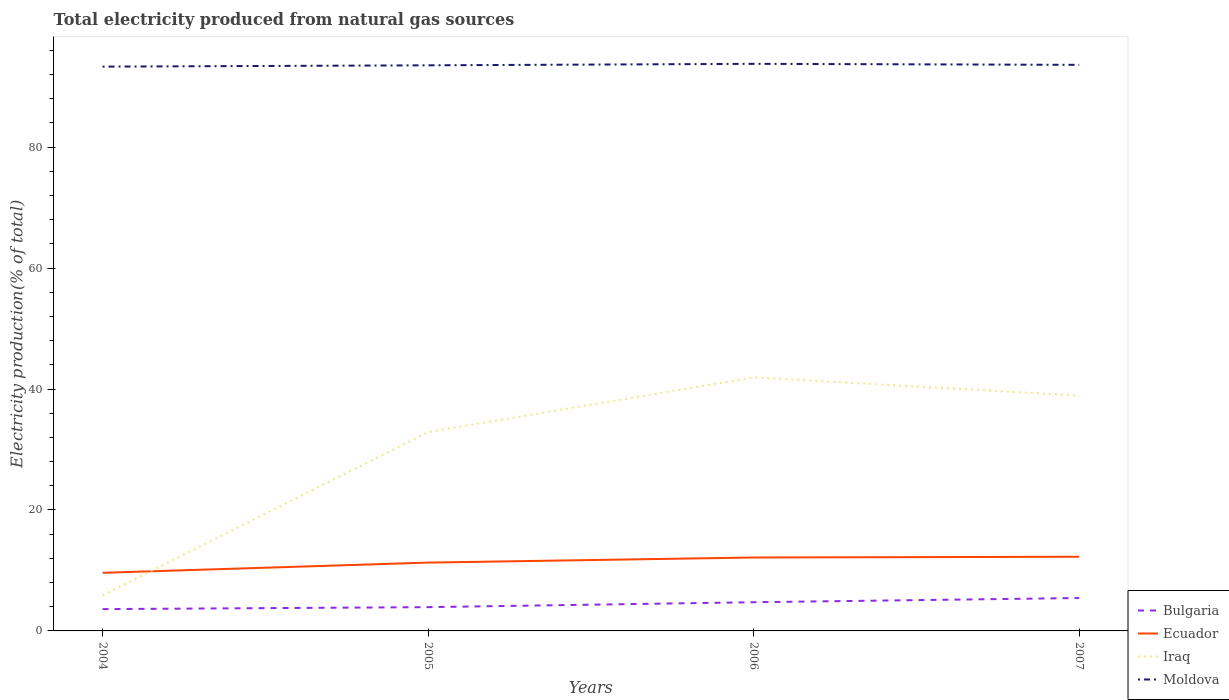How many different coloured lines are there?
Offer a terse response. 4. Does the line corresponding to Moldova intersect with the line corresponding to Bulgaria?
Your answer should be very brief. No. Across all years, what is the maximum total electricity produced in Moldova?
Provide a short and direct response. 93.32. What is the total total electricity produced in Iraq in the graph?
Provide a short and direct response. -33.04. What is the difference between the highest and the second highest total electricity produced in Bulgaria?
Your response must be concise. 1.83. Is the total electricity produced in Ecuador strictly greater than the total electricity produced in Moldova over the years?
Give a very brief answer. Yes. How many lines are there?
Your response must be concise. 4. How many years are there in the graph?
Your answer should be very brief. 4. How are the legend labels stacked?
Offer a very short reply. Vertical. What is the title of the graph?
Provide a short and direct response. Total electricity produced from natural gas sources. Does "Ireland" appear as one of the legend labels in the graph?
Offer a very short reply. No. What is the label or title of the X-axis?
Give a very brief answer. Years. What is the label or title of the Y-axis?
Keep it short and to the point. Electricity production(% of total). What is the Electricity production(% of total) of Bulgaria in 2004?
Your response must be concise. 3.61. What is the Electricity production(% of total) in Ecuador in 2004?
Offer a terse response. 9.61. What is the Electricity production(% of total) in Iraq in 2004?
Offer a very short reply. 5.88. What is the Electricity production(% of total) of Moldova in 2004?
Give a very brief answer. 93.32. What is the Electricity production(% of total) in Bulgaria in 2005?
Your response must be concise. 3.93. What is the Electricity production(% of total) of Ecuador in 2005?
Make the answer very short. 11.3. What is the Electricity production(% of total) of Iraq in 2005?
Offer a terse response. 32.89. What is the Electricity production(% of total) of Moldova in 2005?
Keep it short and to the point. 93.54. What is the Electricity production(% of total) in Bulgaria in 2006?
Offer a very short reply. 4.74. What is the Electricity production(% of total) of Ecuador in 2006?
Your response must be concise. 12.14. What is the Electricity production(% of total) in Iraq in 2006?
Provide a short and direct response. 41.93. What is the Electricity production(% of total) of Moldova in 2006?
Offer a very short reply. 93.78. What is the Electricity production(% of total) of Bulgaria in 2007?
Keep it short and to the point. 5.44. What is the Electricity production(% of total) of Ecuador in 2007?
Ensure brevity in your answer.  12.27. What is the Electricity production(% of total) of Iraq in 2007?
Provide a succinct answer. 38.92. What is the Electricity production(% of total) in Moldova in 2007?
Give a very brief answer. 93.62. Across all years, what is the maximum Electricity production(% of total) of Bulgaria?
Ensure brevity in your answer.  5.44. Across all years, what is the maximum Electricity production(% of total) of Ecuador?
Give a very brief answer. 12.27. Across all years, what is the maximum Electricity production(% of total) in Iraq?
Offer a very short reply. 41.93. Across all years, what is the maximum Electricity production(% of total) in Moldova?
Make the answer very short. 93.78. Across all years, what is the minimum Electricity production(% of total) of Bulgaria?
Give a very brief answer. 3.61. Across all years, what is the minimum Electricity production(% of total) of Ecuador?
Offer a very short reply. 9.61. Across all years, what is the minimum Electricity production(% of total) in Iraq?
Your answer should be compact. 5.88. Across all years, what is the minimum Electricity production(% of total) in Moldova?
Make the answer very short. 93.32. What is the total Electricity production(% of total) of Bulgaria in the graph?
Offer a terse response. 17.72. What is the total Electricity production(% of total) of Ecuador in the graph?
Make the answer very short. 45.32. What is the total Electricity production(% of total) of Iraq in the graph?
Give a very brief answer. 119.63. What is the total Electricity production(% of total) in Moldova in the graph?
Offer a terse response. 374.26. What is the difference between the Electricity production(% of total) of Bulgaria in 2004 and that in 2005?
Your response must be concise. -0.33. What is the difference between the Electricity production(% of total) in Ecuador in 2004 and that in 2005?
Offer a very short reply. -1.69. What is the difference between the Electricity production(% of total) of Iraq in 2004 and that in 2005?
Make the answer very short. -27.01. What is the difference between the Electricity production(% of total) of Moldova in 2004 and that in 2005?
Your answer should be compact. -0.22. What is the difference between the Electricity production(% of total) of Bulgaria in 2004 and that in 2006?
Ensure brevity in your answer.  -1.14. What is the difference between the Electricity production(% of total) of Ecuador in 2004 and that in 2006?
Your answer should be very brief. -2.53. What is the difference between the Electricity production(% of total) in Iraq in 2004 and that in 2006?
Your answer should be compact. -36.05. What is the difference between the Electricity production(% of total) in Moldova in 2004 and that in 2006?
Your response must be concise. -0.46. What is the difference between the Electricity production(% of total) of Bulgaria in 2004 and that in 2007?
Make the answer very short. -1.83. What is the difference between the Electricity production(% of total) in Ecuador in 2004 and that in 2007?
Make the answer very short. -2.66. What is the difference between the Electricity production(% of total) in Iraq in 2004 and that in 2007?
Provide a succinct answer. -33.04. What is the difference between the Electricity production(% of total) in Moldova in 2004 and that in 2007?
Ensure brevity in your answer.  -0.29. What is the difference between the Electricity production(% of total) in Bulgaria in 2005 and that in 2006?
Your answer should be compact. -0.81. What is the difference between the Electricity production(% of total) of Ecuador in 2005 and that in 2006?
Offer a terse response. -0.84. What is the difference between the Electricity production(% of total) in Iraq in 2005 and that in 2006?
Your answer should be very brief. -9.04. What is the difference between the Electricity production(% of total) in Moldova in 2005 and that in 2006?
Keep it short and to the point. -0.24. What is the difference between the Electricity production(% of total) in Bulgaria in 2005 and that in 2007?
Offer a very short reply. -1.51. What is the difference between the Electricity production(% of total) in Ecuador in 2005 and that in 2007?
Provide a short and direct response. -0.97. What is the difference between the Electricity production(% of total) in Iraq in 2005 and that in 2007?
Make the answer very short. -6.03. What is the difference between the Electricity production(% of total) in Moldova in 2005 and that in 2007?
Your response must be concise. -0.08. What is the difference between the Electricity production(% of total) of Bulgaria in 2006 and that in 2007?
Your answer should be very brief. -0.7. What is the difference between the Electricity production(% of total) of Ecuador in 2006 and that in 2007?
Offer a terse response. -0.12. What is the difference between the Electricity production(% of total) of Iraq in 2006 and that in 2007?
Make the answer very short. 3.01. What is the difference between the Electricity production(% of total) of Moldova in 2006 and that in 2007?
Provide a short and direct response. 0.17. What is the difference between the Electricity production(% of total) of Bulgaria in 2004 and the Electricity production(% of total) of Ecuador in 2005?
Offer a very short reply. -7.69. What is the difference between the Electricity production(% of total) in Bulgaria in 2004 and the Electricity production(% of total) in Iraq in 2005?
Provide a short and direct response. -29.29. What is the difference between the Electricity production(% of total) in Bulgaria in 2004 and the Electricity production(% of total) in Moldova in 2005?
Provide a succinct answer. -89.93. What is the difference between the Electricity production(% of total) of Ecuador in 2004 and the Electricity production(% of total) of Iraq in 2005?
Your answer should be compact. -23.29. What is the difference between the Electricity production(% of total) in Ecuador in 2004 and the Electricity production(% of total) in Moldova in 2005?
Give a very brief answer. -83.93. What is the difference between the Electricity production(% of total) in Iraq in 2004 and the Electricity production(% of total) in Moldova in 2005?
Your response must be concise. -87.66. What is the difference between the Electricity production(% of total) in Bulgaria in 2004 and the Electricity production(% of total) in Ecuador in 2006?
Give a very brief answer. -8.54. What is the difference between the Electricity production(% of total) in Bulgaria in 2004 and the Electricity production(% of total) in Iraq in 2006?
Offer a very short reply. -38.32. What is the difference between the Electricity production(% of total) in Bulgaria in 2004 and the Electricity production(% of total) in Moldova in 2006?
Keep it short and to the point. -90.18. What is the difference between the Electricity production(% of total) in Ecuador in 2004 and the Electricity production(% of total) in Iraq in 2006?
Your response must be concise. -32.32. What is the difference between the Electricity production(% of total) in Ecuador in 2004 and the Electricity production(% of total) in Moldova in 2006?
Your answer should be compact. -84.17. What is the difference between the Electricity production(% of total) in Iraq in 2004 and the Electricity production(% of total) in Moldova in 2006?
Make the answer very short. -87.9. What is the difference between the Electricity production(% of total) of Bulgaria in 2004 and the Electricity production(% of total) of Ecuador in 2007?
Keep it short and to the point. -8.66. What is the difference between the Electricity production(% of total) in Bulgaria in 2004 and the Electricity production(% of total) in Iraq in 2007?
Give a very brief answer. -35.31. What is the difference between the Electricity production(% of total) in Bulgaria in 2004 and the Electricity production(% of total) in Moldova in 2007?
Make the answer very short. -90.01. What is the difference between the Electricity production(% of total) of Ecuador in 2004 and the Electricity production(% of total) of Iraq in 2007?
Keep it short and to the point. -29.31. What is the difference between the Electricity production(% of total) in Ecuador in 2004 and the Electricity production(% of total) in Moldova in 2007?
Give a very brief answer. -84.01. What is the difference between the Electricity production(% of total) in Iraq in 2004 and the Electricity production(% of total) in Moldova in 2007?
Provide a short and direct response. -87.73. What is the difference between the Electricity production(% of total) in Bulgaria in 2005 and the Electricity production(% of total) in Ecuador in 2006?
Your response must be concise. -8.21. What is the difference between the Electricity production(% of total) of Bulgaria in 2005 and the Electricity production(% of total) of Iraq in 2006?
Offer a very short reply. -38. What is the difference between the Electricity production(% of total) in Bulgaria in 2005 and the Electricity production(% of total) in Moldova in 2006?
Keep it short and to the point. -89.85. What is the difference between the Electricity production(% of total) in Ecuador in 2005 and the Electricity production(% of total) in Iraq in 2006?
Provide a short and direct response. -30.63. What is the difference between the Electricity production(% of total) in Ecuador in 2005 and the Electricity production(% of total) in Moldova in 2006?
Keep it short and to the point. -82.48. What is the difference between the Electricity production(% of total) in Iraq in 2005 and the Electricity production(% of total) in Moldova in 2006?
Ensure brevity in your answer.  -60.89. What is the difference between the Electricity production(% of total) of Bulgaria in 2005 and the Electricity production(% of total) of Ecuador in 2007?
Make the answer very short. -8.33. What is the difference between the Electricity production(% of total) in Bulgaria in 2005 and the Electricity production(% of total) in Iraq in 2007?
Offer a terse response. -34.99. What is the difference between the Electricity production(% of total) in Bulgaria in 2005 and the Electricity production(% of total) in Moldova in 2007?
Your answer should be very brief. -89.68. What is the difference between the Electricity production(% of total) in Ecuador in 2005 and the Electricity production(% of total) in Iraq in 2007?
Offer a terse response. -27.62. What is the difference between the Electricity production(% of total) of Ecuador in 2005 and the Electricity production(% of total) of Moldova in 2007?
Your answer should be compact. -82.32. What is the difference between the Electricity production(% of total) of Iraq in 2005 and the Electricity production(% of total) of Moldova in 2007?
Your answer should be compact. -60.72. What is the difference between the Electricity production(% of total) in Bulgaria in 2006 and the Electricity production(% of total) in Ecuador in 2007?
Provide a short and direct response. -7.52. What is the difference between the Electricity production(% of total) of Bulgaria in 2006 and the Electricity production(% of total) of Iraq in 2007?
Make the answer very short. -34.18. What is the difference between the Electricity production(% of total) in Bulgaria in 2006 and the Electricity production(% of total) in Moldova in 2007?
Keep it short and to the point. -88.87. What is the difference between the Electricity production(% of total) in Ecuador in 2006 and the Electricity production(% of total) in Iraq in 2007?
Offer a terse response. -26.78. What is the difference between the Electricity production(% of total) in Ecuador in 2006 and the Electricity production(% of total) in Moldova in 2007?
Your answer should be very brief. -81.47. What is the difference between the Electricity production(% of total) in Iraq in 2006 and the Electricity production(% of total) in Moldova in 2007?
Offer a terse response. -51.69. What is the average Electricity production(% of total) of Bulgaria per year?
Provide a short and direct response. 4.43. What is the average Electricity production(% of total) of Ecuador per year?
Provide a succinct answer. 11.33. What is the average Electricity production(% of total) of Iraq per year?
Offer a very short reply. 29.91. What is the average Electricity production(% of total) of Moldova per year?
Provide a succinct answer. 93.57. In the year 2004, what is the difference between the Electricity production(% of total) of Bulgaria and Electricity production(% of total) of Ecuador?
Provide a short and direct response. -6. In the year 2004, what is the difference between the Electricity production(% of total) in Bulgaria and Electricity production(% of total) in Iraq?
Give a very brief answer. -2.28. In the year 2004, what is the difference between the Electricity production(% of total) in Bulgaria and Electricity production(% of total) in Moldova?
Your answer should be compact. -89.72. In the year 2004, what is the difference between the Electricity production(% of total) of Ecuador and Electricity production(% of total) of Iraq?
Ensure brevity in your answer.  3.73. In the year 2004, what is the difference between the Electricity production(% of total) of Ecuador and Electricity production(% of total) of Moldova?
Make the answer very short. -83.71. In the year 2004, what is the difference between the Electricity production(% of total) in Iraq and Electricity production(% of total) in Moldova?
Offer a very short reply. -87.44. In the year 2005, what is the difference between the Electricity production(% of total) of Bulgaria and Electricity production(% of total) of Ecuador?
Offer a very short reply. -7.37. In the year 2005, what is the difference between the Electricity production(% of total) of Bulgaria and Electricity production(% of total) of Iraq?
Ensure brevity in your answer.  -28.96. In the year 2005, what is the difference between the Electricity production(% of total) of Bulgaria and Electricity production(% of total) of Moldova?
Offer a very short reply. -89.61. In the year 2005, what is the difference between the Electricity production(% of total) in Ecuador and Electricity production(% of total) in Iraq?
Your response must be concise. -21.59. In the year 2005, what is the difference between the Electricity production(% of total) of Ecuador and Electricity production(% of total) of Moldova?
Your response must be concise. -82.24. In the year 2005, what is the difference between the Electricity production(% of total) in Iraq and Electricity production(% of total) in Moldova?
Make the answer very short. -60.64. In the year 2006, what is the difference between the Electricity production(% of total) of Bulgaria and Electricity production(% of total) of Ecuador?
Your response must be concise. -7.4. In the year 2006, what is the difference between the Electricity production(% of total) in Bulgaria and Electricity production(% of total) in Iraq?
Keep it short and to the point. -37.19. In the year 2006, what is the difference between the Electricity production(% of total) in Bulgaria and Electricity production(% of total) in Moldova?
Provide a succinct answer. -89.04. In the year 2006, what is the difference between the Electricity production(% of total) in Ecuador and Electricity production(% of total) in Iraq?
Your answer should be very brief. -29.79. In the year 2006, what is the difference between the Electricity production(% of total) of Ecuador and Electricity production(% of total) of Moldova?
Offer a terse response. -81.64. In the year 2006, what is the difference between the Electricity production(% of total) in Iraq and Electricity production(% of total) in Moldova?
Your response must be concise. -51.85. In the year 2007, what is the difference between the Electricity production(% of total) in Bulgaria and Electricity production(% of total) in Ecuador?
Offer a very short reply. -6.83. In the year 2007, what is the difference between the Electricity production(% of total) of Bulgaria and Electricity production(% of total) of Iraq?
Your answer should be very brief. -33.48. In the year 2007, what is the difference between the Electricity production(% of total) in Bulgaria and Electricity production(% of total) in Moldova?
Your answer should be very brief. -88.18. In the year 2007, what is the difference between the Electricity production(% of total) in Ecuador and Electricity production(% of total) in Iraq?
Offer a terse response. -26.65. In the year 2007, what is the difference between the Electricity production(% of total) of Ecuador and Electricity production(% of total) of Moldova?
Provide a short and direct response. -81.35. In the year 2007, what is the difference between the Electricity production(% of total) of Iraq and Electricity production(% of total) of Moldova?
Offer a terse response. -54.7. What is the ratio of the Electricity production(% of total) of Bulgaria in 2004 to that in 2005?
Your answer should be very brief. 0.92. What is the ratio of the Electricity production(% of total) of Ecuador in 2004 to that in 2005?
Offer a terse response. 0.85. What is the ratio of the Electricity production(% of total) in Iraq in 2004 to that in 2005?
Keep it short and to the point. 0.18. What is the ratio of the Electricity production(% of total) in Bulgaria in 2004 to that in 2006?
Keep it short and to the point. 0.76. What is the ratio of the Electricity production(% of total) in Ecuador in 2004 to that in 2006?
Your answer should be very brief. 0.79. What is the ratio of the Electricity production(% of total) of Iraq in 2004 to that in 2006?
Provide a short and direct response. 0.14. What is the ratio of the Electricity production(% of total) of Bulgaria in 2004 to that in 2007?
Your answer should be very brief. 0.66. What is the ratio of the Electricity production(% of total) in Ecuador in 2004 to that in 2007?
Keep it short and to the point. 0.78. What is the ratio of the Electricity production(% of total) of Iraq in 2004 to that in 2007?
Offer a terse response. 0.15. What is the ratio of the Electricity production(% of total) of Moldova in 2004 to that in 2007?
Ensure brevity in your answer.  1. What is the ratio of the Electricity production(% of total) of Bulgaria in 2005 to that in 2006?
Keep it short and to the point. 0.83. What is the ratio of the Electricity production(% of total) in Ecuador in 2005 to that in 2006?
Ensure brevity in your answer.  0.93. What is the ratio of the Electricity production(% of total) in Iraq in 2005 to that in 2006?
Ensure brevity in your answer.  0.78. What is the ratio of the Electricity production(% of total) in Bulgaria in 2005 to that in 2007?
Keep it short and to the point. 0.72. What is the ratio of the Electricity production(% of total) of Ecuador in 2005 to that in 2007?
Keep it short and to the point. 0.92. What is the ratio of the Electricity production(% of total) of Iraq in 2005 to that in 2007?
Make the answer very short. 0.85. What is the ratio of the Electricity production(% of total) in Moldova in 2005 to that in 2007?
Provide a succinct answer. 1. What is the ratio of the Electricity production(% of total) in Bulgaria in 2006 to that in 2007?
Give a very brief answer. 0.87. What is the ratio of the Electricity production(% of total) in Iraq in 2006 to that in 2007?
Ensure brevity in your answer.  1.08. What is the difference between the highest and the second highest Electricity production(% of total) of Bulgaria?
Your response must be concise. 0.7. What is the difference between the highest and the second highest Electricity production(% of total) in Ecuador?
Offer a terse response. 0.12. What is the difference between the highest and the second highest Electricity production(% of total) of Iraq?
Ensure brevity in your answer.  3.01. What is the difference between the highest and the second highest Electricity production(% of total) of Moldova?
Keep it short and to the point. 0.17. What is the difference between the highest and the lowest Electricity production(% of total) of Bulgaria?
Your answer should be compact. 1.83. What is the difference between the highest and the lowest Electricity production(% of total) in Ecuador?
Your answer should be very brief. 2.66. What is the difference between the highest and the lowest Electricity production(% of total) in Iraq?
Provide a short and direct response. 36.05. What is the difference between the highest and the lowest Electricity production(% of total) in Moldova?
Keep it short and to the point. 0.46. 